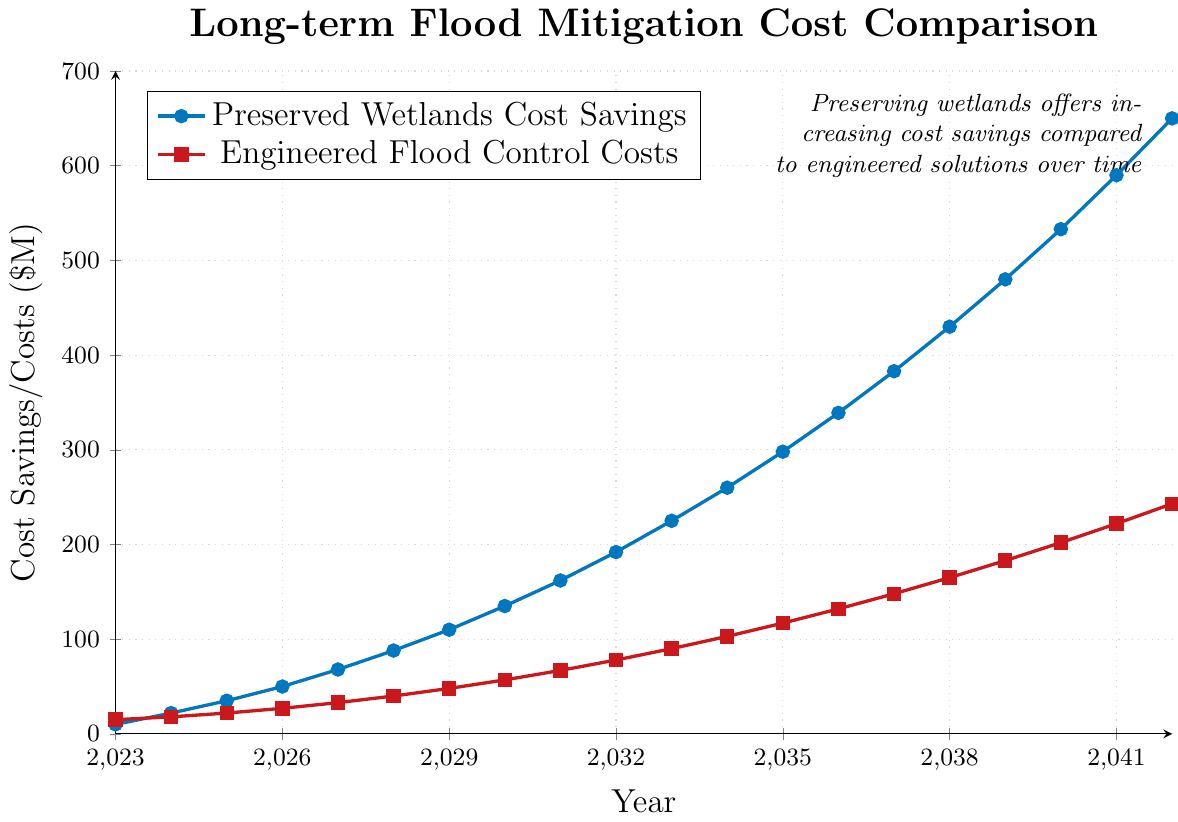What are the cost savings from preserved wetlands in 2030? The cost savings from preserved wetlands in 2030 can be directly read from the plot, which shows both the x-axis (Year) and y-axis (Cost Savings/Costs). Locate the year 2030 on the x-axis and find the corresponding value on the y-axis.
Answer: $135M How much higher are the cost savings from preserved wetlands compared to engineered flood control costs in 2042? To find this, locate the values for both preserved wetlands and engineered flood control costs for the year 2042 on the x-axis. The cost savings for preserved wetlands is $650M and the cost for engineered flood control measures is $243M. Subtract the latter from the former: $650M - $243M.
Answer: $407M In which year do the preserved wetlands' cost savings surpass $100M? To find this, observe the values on the y-axis and look for the first year where the preserved wetlands' cost savings exceed $100M. Based on the plot, this occurs in 2029.
Answer: 2029 What is the difference in cost savings between 2035 and 2040 for preserved wetlands? First, find the cost savings for preserved wetlands in 2035 and 2040, which are $298M and $533M respectively, then subtract the former from the latter: $533M - $298M.
Answer: $235M What is the growth rate of preserved wetlands' cost savings from 2023 to 2024? Identify the values for 2023 and 2024, which are $10M and $22M respectively. The growth rate is computed by the formula (New Value - Old Value) / Old Value. So, ($22M - $10M) / $10M = $12M / $10M * 100%.
Answer: 120% When do the engineered flood control costs first exceed $50M? Locate the point on the x-axis where the engineered flood control costs (represented by red squares) first surpass $50M. Based on the plot, this happens in 2029.
Answer: 2029 What are the comparative costs of preserved wetlands and engineered flood control in 2037? In 2037, preserved wetlands' cost savings are $383M while engineered flood control costs are $148M. Compare both values directly.
Answer: $383M vs. $148M By how much do the cost savings from preserved wetlands increase each year by 2042 on average? Calculate the total increase from 2023 ($10M) to 2042 ($650M), which is $650M - $10M = $640M. Divide by the number of years (2042 - 2023 = 19 years): $640M / 19 years.
Answer: $33.68M/year What is the visual trend for preserved wetlands' cost savings over the years? Observe the line plot's slope representing preserved wetlands' cost savings. This line continuously increases, suggesting a consistently upward trend in cost savings over time.
Answer: Increasing trend Compare the slope of the cost savings curve for preserved wetlands versus the cost curve for engineered flood control measures. Visually assess the steepness of the lines representing both curves. The slope (steepness) of the preserved wetlands line is greater than that of the engineered flood control line, indicating faster cost savings growth for preserved wetlands.
Answer: Steeper for preserved wetlands 